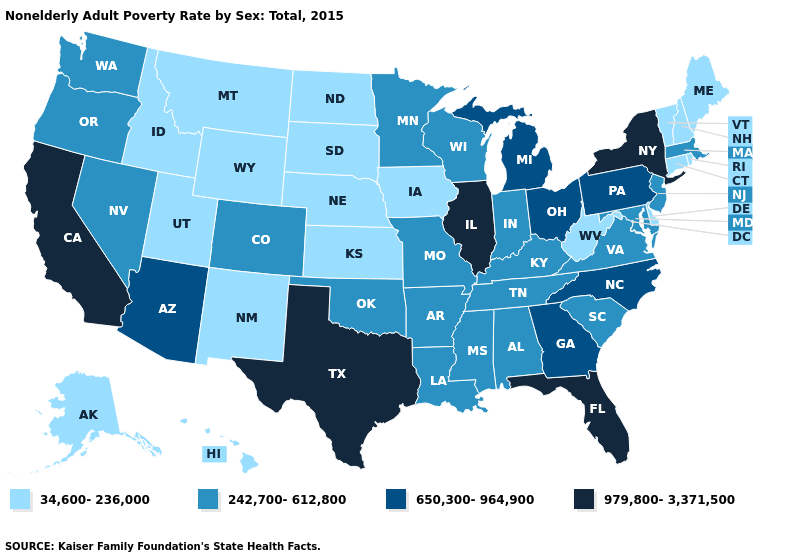What is the value of Utah?
Keep it brief. 34,600-236,000. Does Connecticut have the lowest value in the USA?
Short answer required. Yes. What is the value of Wyoming?
Be succinct. 34,600-236,000. How many symbols are there in the legend?
Keep it brief. 4. What is the value of Georgia?
Give a very brief answer. 650,300-964,900. How many symbols are there in the legend?
Give a very brief answer. 4. Among the states that border Pennsylvania , does West Virginia have the lowest value?
Quick response, please. Yes. Name the states that have a value in the range 242,700-612,800?
Concise answer only. Alabama, Arkansas, Colorado, Indiana, Kentucky, Louisiana, Maryland, Massachusetts, Minnesota, Mississippi, Missouri, Nevada, New Jersey, Oklahoma, Oregon, South Carolina, Tennessee, Virginia, Washington, Wisconsin. Name the states that have a value in the range 34,600-236,000?
Concise answer only. Alaska, Connecticut, Delaware, Hawaii, Idaho, Iowa, Kansas, Maine, Montana, Nebraska, New Hampshire, New Mexico, North Dakota, Rhode Island, South Dakota, Utah, Vermont, West Virginia, Wyoming. What is the highest value in states that border Maine?
Short answer required. 34,600-236,000. Does Ohio have a higher value than Nebraska?
Concise answer only. Yes. What is the lowest value in the USA?
Give a very brief answer. 34,600-236,000. What is the value of Hawaii?
Write a very short answer. 34,600-236,000. What is the value of Wyoming?
Give a very brief answer. 34,600-236,000. What is the lowest value in the South?
Quick response, please. 34,600-236,000. 